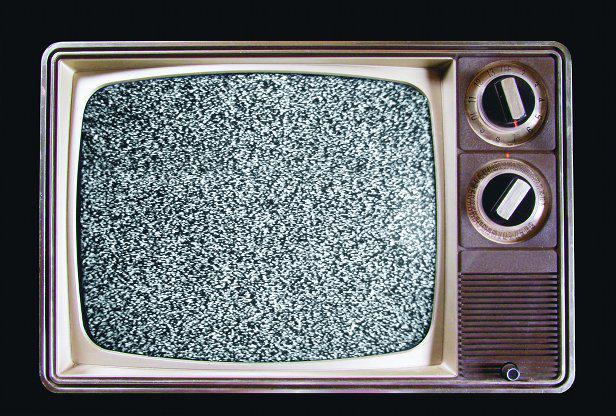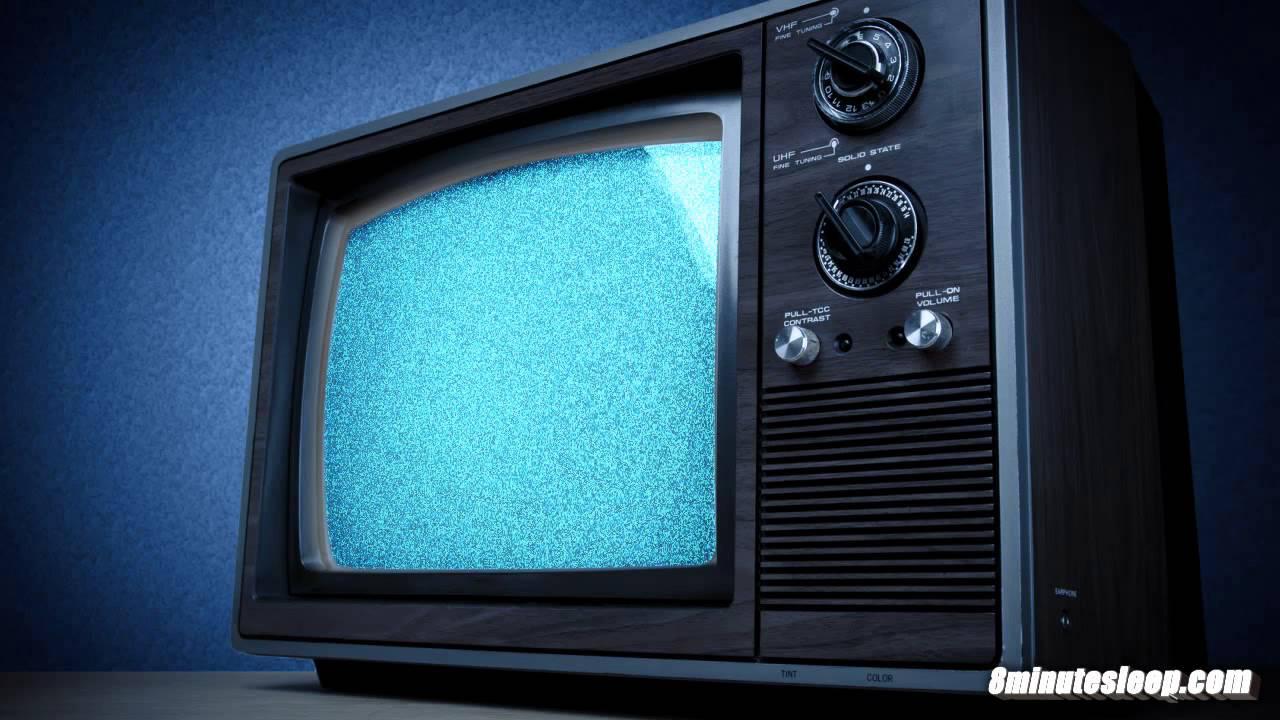The first image is the image on the left, the second image is the image on the right. Assess this claim about the two images: "Each image shows one old-fashioned TV set with grainy static """"fuzz"""" on the screen, and the right image shows a TV set on a solid-colored background.". Correct or not? Answer yes or no. Yes. 